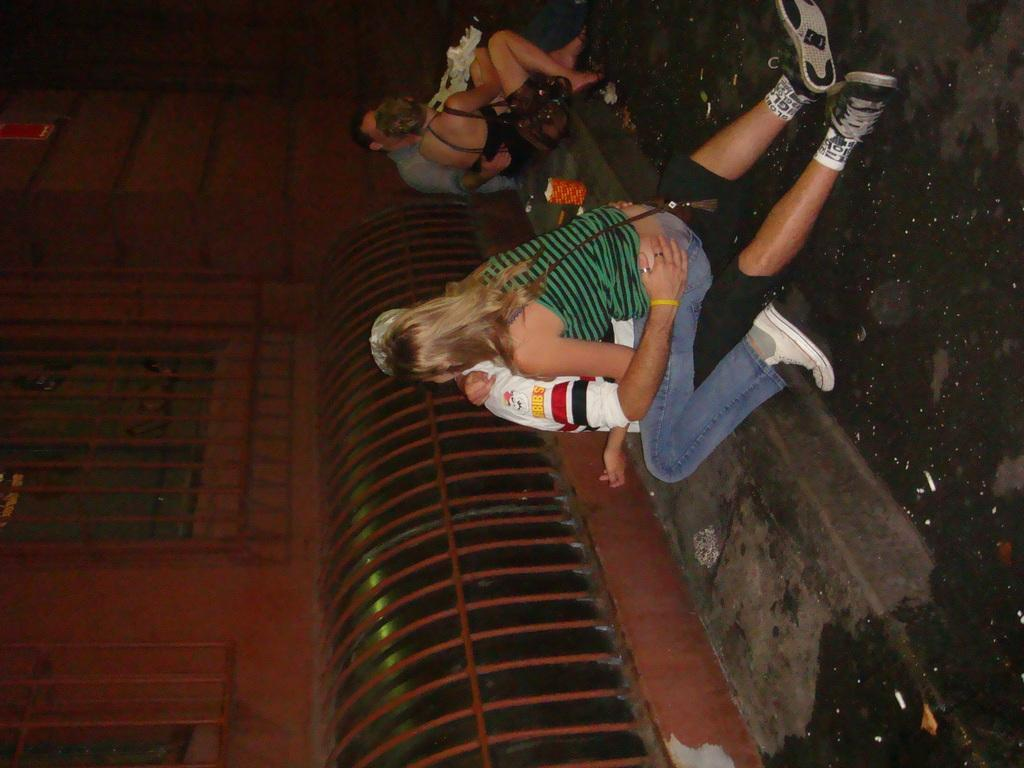What can be inferred about the lighting conditions in the image? The image was taken in a dark environment. How are the four persons positioned in the image? The four persons are sitting on the ground in the middle of the image. What is present on the left side of the image? There is a window on the left side of the image. What is the relationship between the window and the wall in the image? The window is part of a wall. What type of organization is responsible for the care of the animals in the image? There are no animals present in the image, so it is not possible to determine the type of organization responsible for their care. 